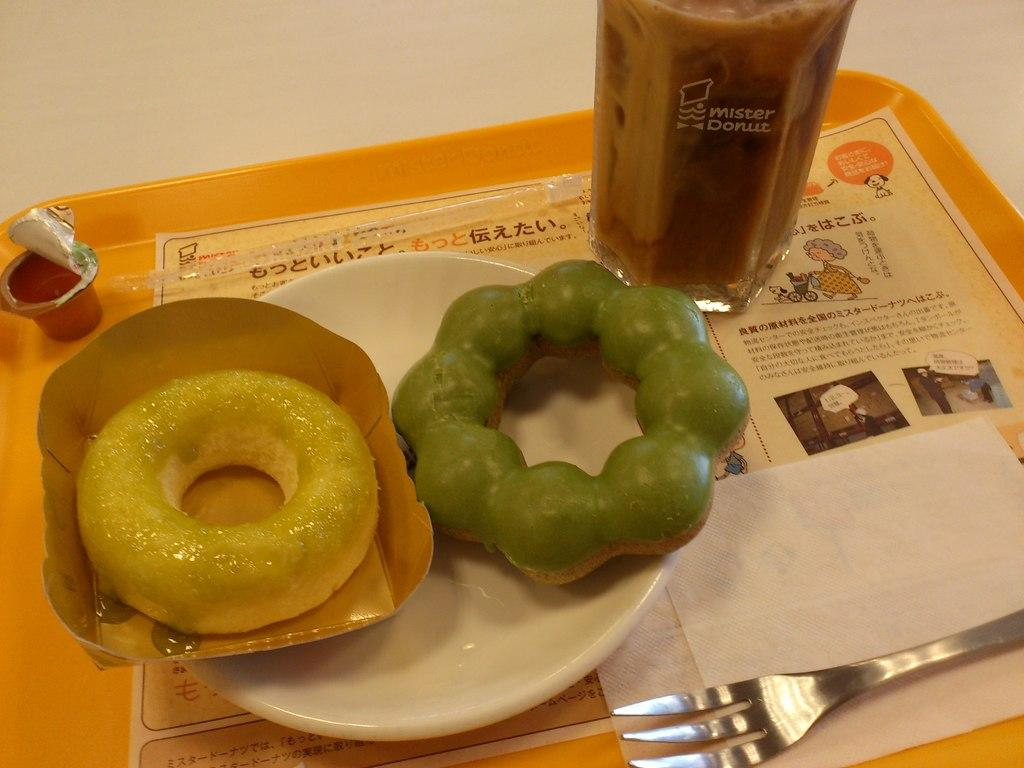What object is present in the image that can hold multiple items? There is a tray in the image that can hold multiple items. What type of paper can be seen on the tray? There is a paper on the tray. What is used for cleaning or wiping on the tray? There is a tissue on the tray. What utensil is present on the tray? There is a fork on the tray. What type of beverage container is on the tray? There is a glass of drink on the tray. What is the main dish on the tray? There is a plate on the tray, and it contains a doughnut and other food. What type of cable is visible in the image? There is no cable present in the image. What type of writing can be seen on the paper? There is no writing visible on the paper in the image. 